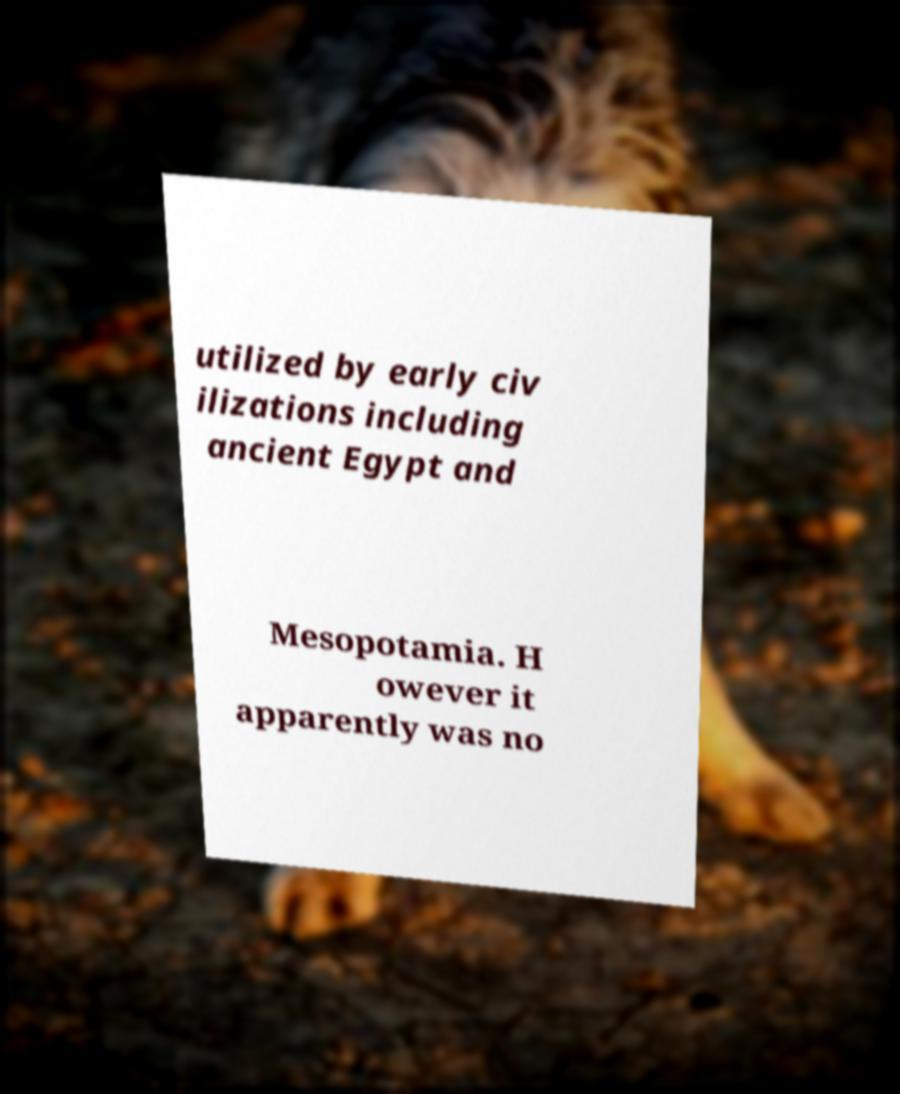Please read and relay the text visible in this image. What does it say? utilized by early civ ilizations including ancient Egypt and Mesopotamia. H owever it apparently was no 